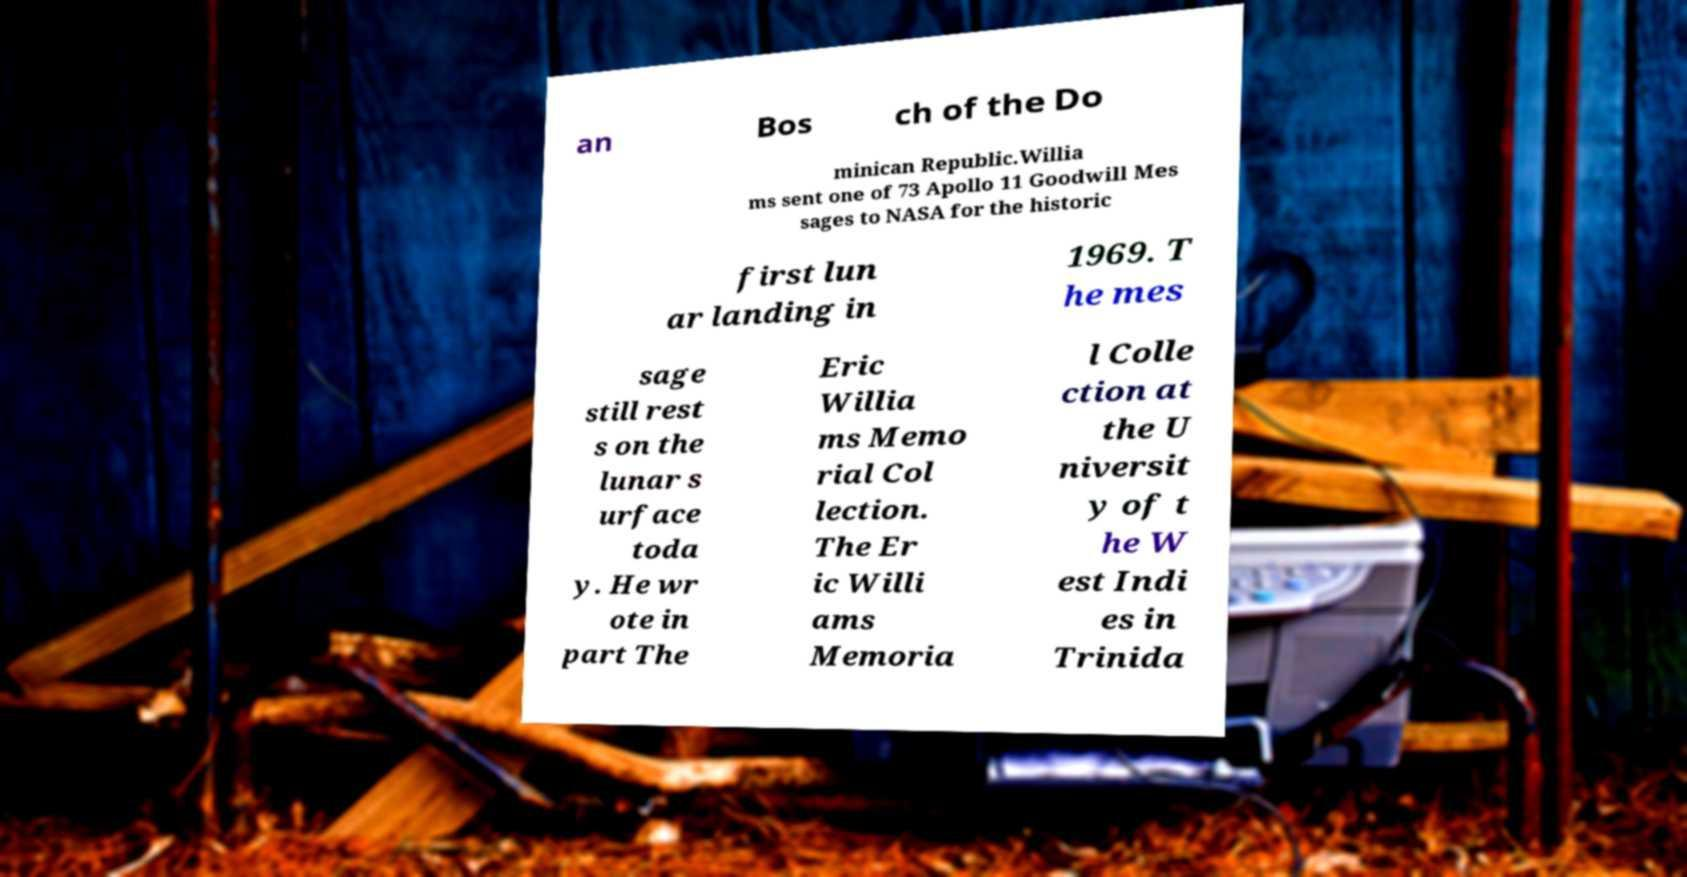Could you assist in decoding the text presented in this image and type it out clearly? an Bos ch of the Do minican Republic.Willia ms sent one of 73 Apollo 11 Goodwill Mes sages to NASA for the historic first lun ar landing in 1969. T he mes sage still rest s on the lunar s urface toda y. He wr ote in part The Eric Willia ms Memo rial Col lection. The Er ic Willi ams Memoria l Colle ction at the U niversit y of t he W est Indi es in Trinida 